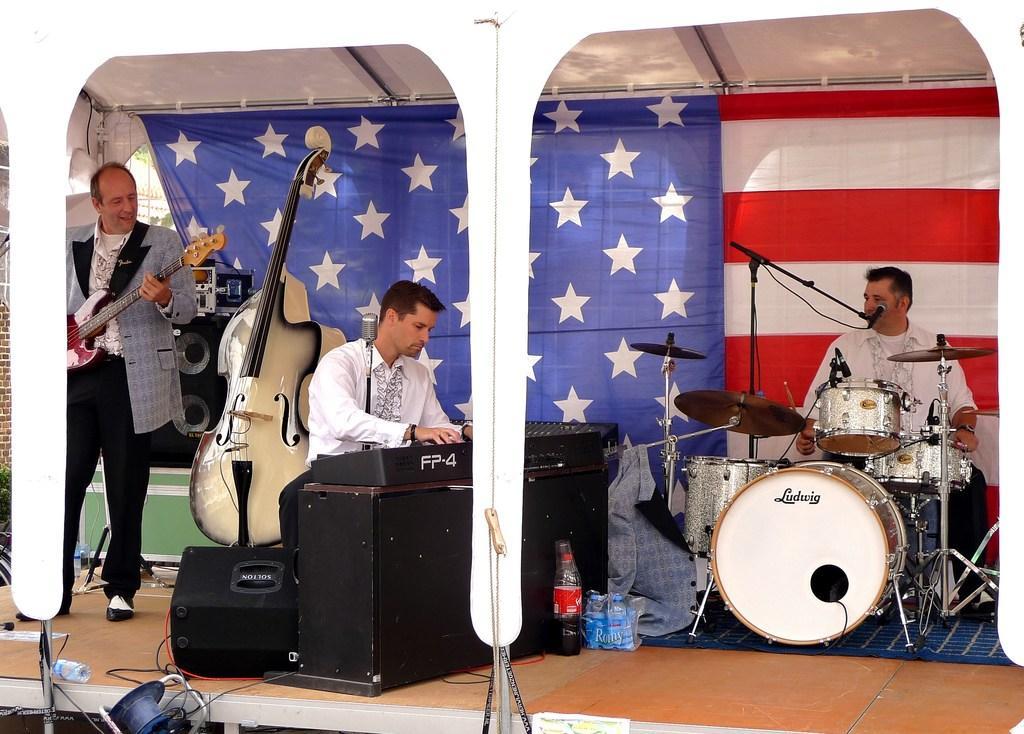Describe this image in one or two sentences. In this image there are three people, one person is standing and playing guitar, another one person is sitting and playing some musical instrument and other person is sitting and playing drums. At the back there is a flag, at the bottom there are bottles, glass, wires. 